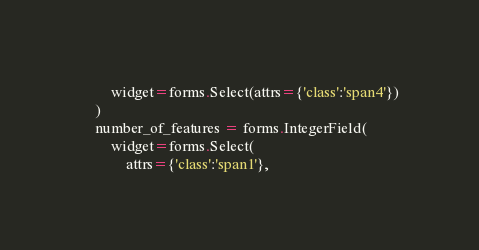Convert code to text. <code><loc_0><loc_0><loc_500><loc_500><_Python_>        widget=forms.Select(attrs={'class':'span4'})
    )
    number_of_features = forms.IntegerField(
        widget=forms.Select(
            attrs={'class':'span1'},</code> 